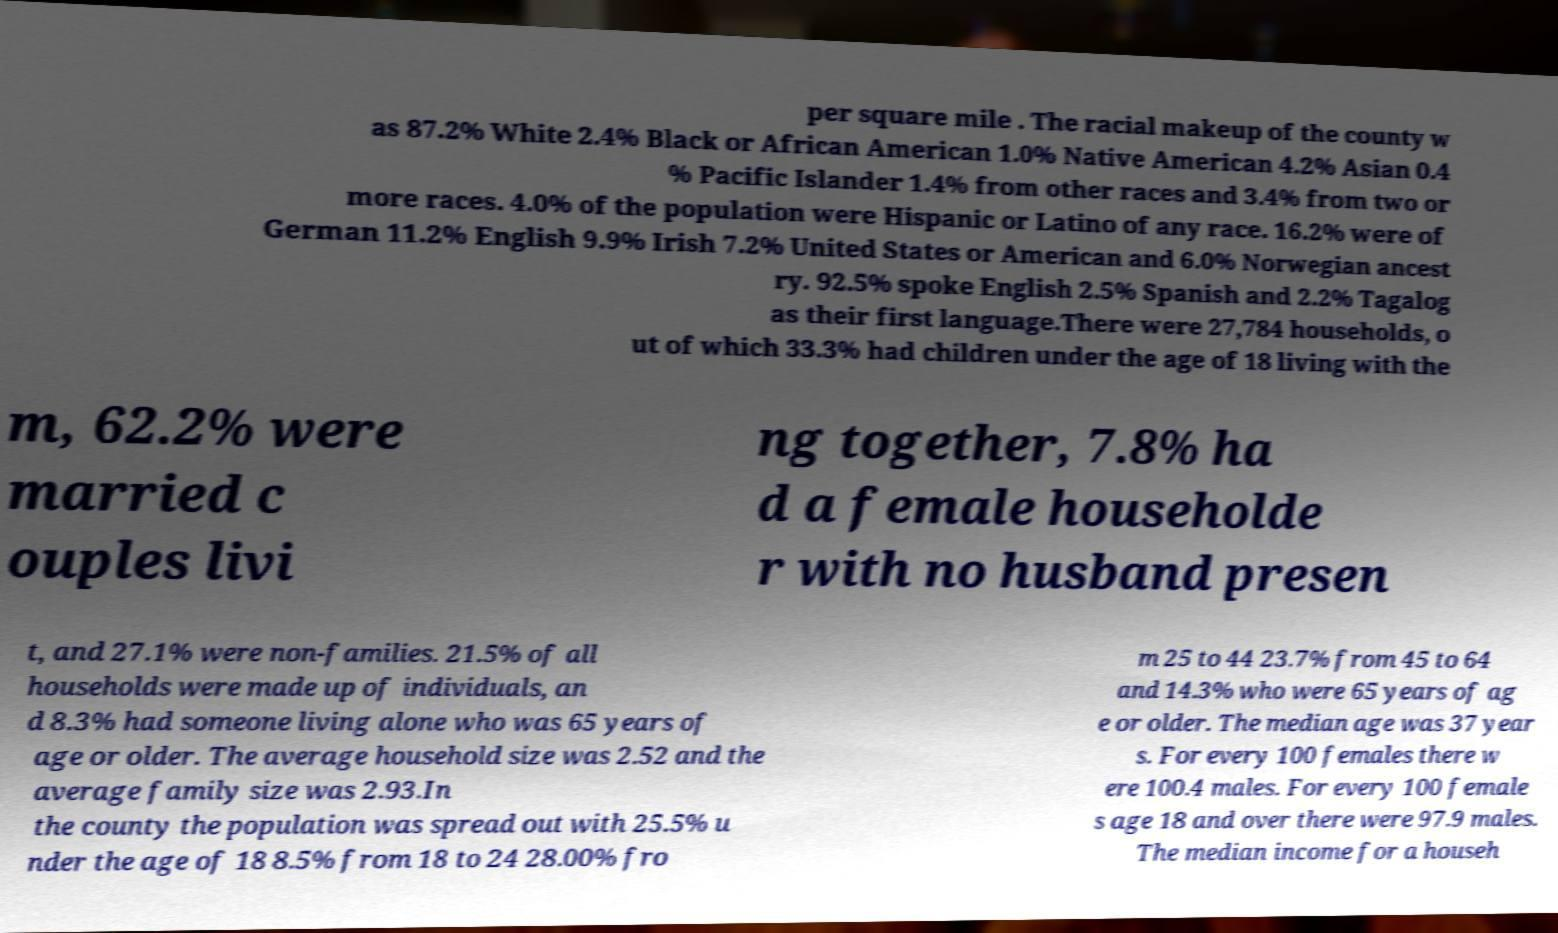Could you assist in decoding the text presented in this image and type it out clearly? per square mile . The racial makeup of the county w as 87.2% White 2.4% Black or African American 1.0% Native American 4.2% Asian 0.4 % Pacific Islander 1.4% from other races and 3.4% from two or more races. 4.0% of the population were Hispanic or Latino of any race. 16.2% were of German 11.2% English 9.9% Irish 7.2% United States or American and 6.0% Norwegian ancest ry. 92.5% spoke English 2.5% Spanish and 2.2% Tagalog as their first language.There were 27,784 households, o ut of which 33.3% had children under the age of 18 living with the m, 62.2% were married c ouples livi ng together, 7.8% ha d a female householde r with no husband presen t, and 27.1% were non-families. 21.5% of all households were made up of individuals, an d 8.3% had someone living alone who was 65 years of age or older. The average household size was 2.52 and the average family size was 2.93.In the county the population was spread out with 25.5% u nder the age of 18 8.5% from 18 to 24 28.00% fro m 25 to 44 23.7% from 45 to 64 and 14.3% who were 65 years of ag e or older. The median age was 37 year s. For every 100 females there w ere 100.4 males. For every 100 female s age 18 and over there were 97.9 males. The median income for a househ 